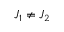<formula> <loc_0><loc_0><loc_500><loc_500>J _ { 1 } \neq J _ { 2 }</formula> 